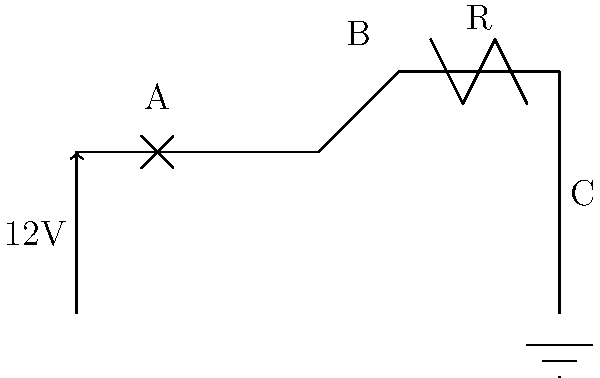In the given circuit diagram of a vehicle's electrical system, what is the purpose of component A, and how does it contribute to the overall system safety? To answer this question, let's analyze the circuit diagram step-by-step:

1. The circuit shows a basic automotive electrical system with a 12V battery, a protective device (A), a switch (between A and B), a resistive load (R), and a ground connection.

2. Component A is located immediately after the positive terminal of the battery and before the switch and load.

3. The symbol for component A consists of two diagonal lines crossing each other inside a rectangle. This is the standard symbol for a fuse in electrical diagrams.

4. A fuse is a safety device designed to protect electrical circuits from overcurrent situations. It contains a metal wire or strip that melts when too much current flows through it, thereby interrupting the circuit and preventing damage to other components.

5. In a vehicle's electrical system, fuses are crucial for protecting various electrical components and wiring from damage due to short circuits or overloads. This is particularly important in automotive applications where electrical faults could lead to fire hazards or critical system failures.

6. The fuse is placed near the battery to provide overall circuit protection. If there's a short circuit or excessive current draw anywhere in the system after the fuse, it will blow and disconnect the circuit from the power source, preventing potential damage or fire.

Therefore, component A (the fuse) contributes to the overall system safety by acting as a sacrificial device that interrupts the circuit in case of overcurrent, protecting the vehicle's electrical components and wiring from damage.
Answer: Component A is a fuse, protecting the circuit from overcurrent by interrupting power flow when excessive current is detected. 